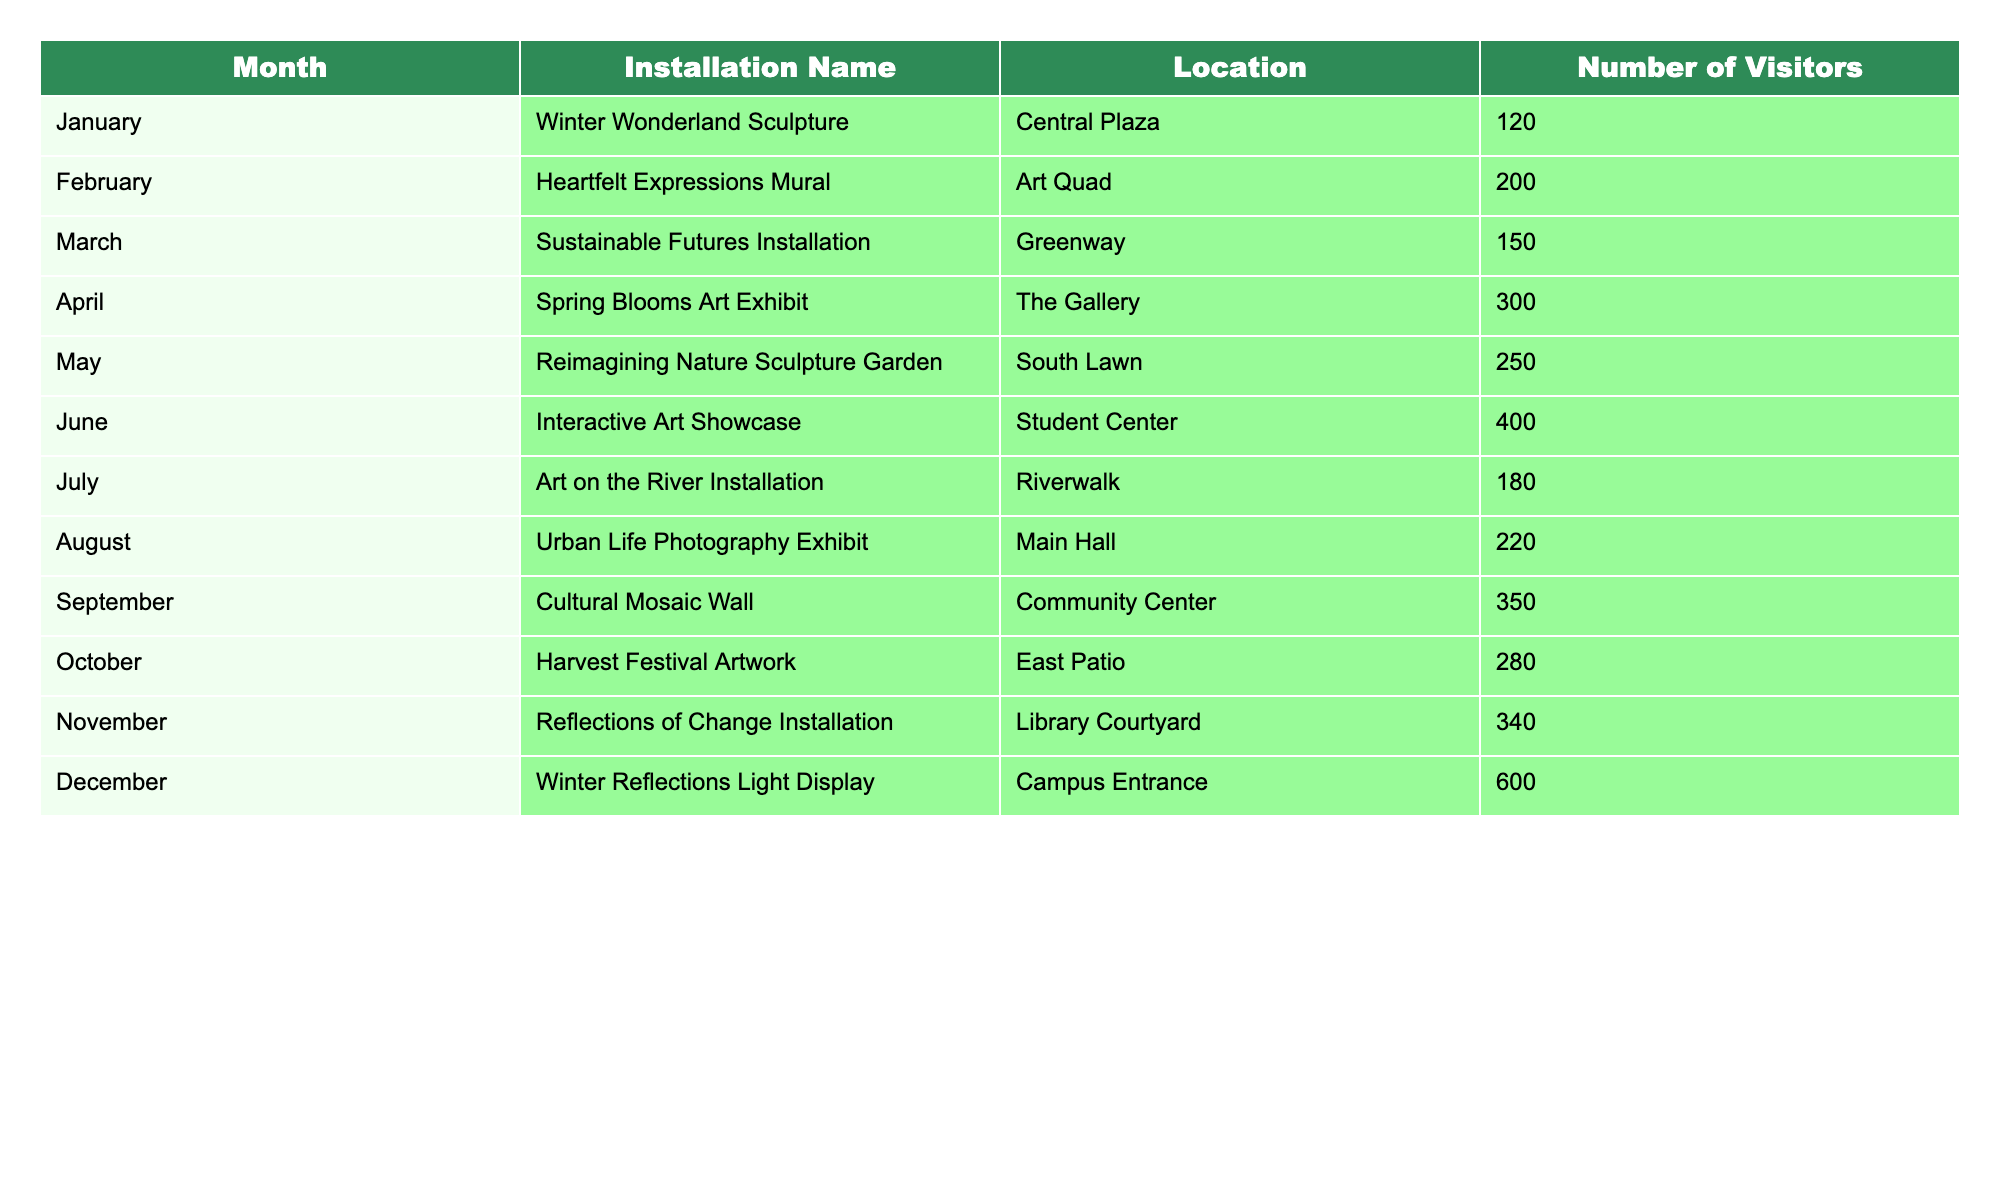What's the total number of visitors for all art installations in December? From the table, the number of visitors for the Winter Reflections Light Display in December is 600. Since this is the only entry for December, the total for that month is simply 600.
Answer: 600 How many visitors did the Spring Blooms Art Exhibit attract? According to the table, the Spring Blooms Art Exhibit in April attracted 300 visitors.
Answer: 300 Which month had the highest number of visitors and what was the count? By examining the table, December had the highest count of 600 visitors with the Winter Reflections Light Display.
Answer: December, 600 What was the average number of visitors across all installations for the year? First, sum all visitors: 120 + 200 + 150 + 300 + 250 + 400 + 180 + 220 + 350 + 280 + 340 + 600 = 3,050. Then, divide by the number of months (12): 3,050 / 12 = 254.17. Therefore, the average number of visitors is 254.17.
Answer: 254.17 Is the number of visitors to the Interactive Art Showcase greater than those to both the Urban Life Photography Exhibit and the Cultural Mosaic Wall combined? The Interactive Art Showcase had 400 visitors, while the Urban Life Photography Exhibit had 220 and the Cultural Mosaic Wall had 350. Adding the latter two gives 220 + 350 = 570. Since 400 is not greater than 570, the answer is no.
Answer: No Which installation had the second highest number of visitors? The table indicates that the second highest number of visitors was for the Reflections of Change Installation in November, which had 340 visitors.
Answer: Reflections of Change Installation, 340 If we remove the month with the lowest visitors, what will be the new total visitors for the year? The month with the lowest visitors is January with 120 visitors. To find the new total, subtract 120 from the previous total (3,050): 3,050 - 120 = 2,930. Therefore, the new total is 2,930 visitors.
Answer: 2,930 